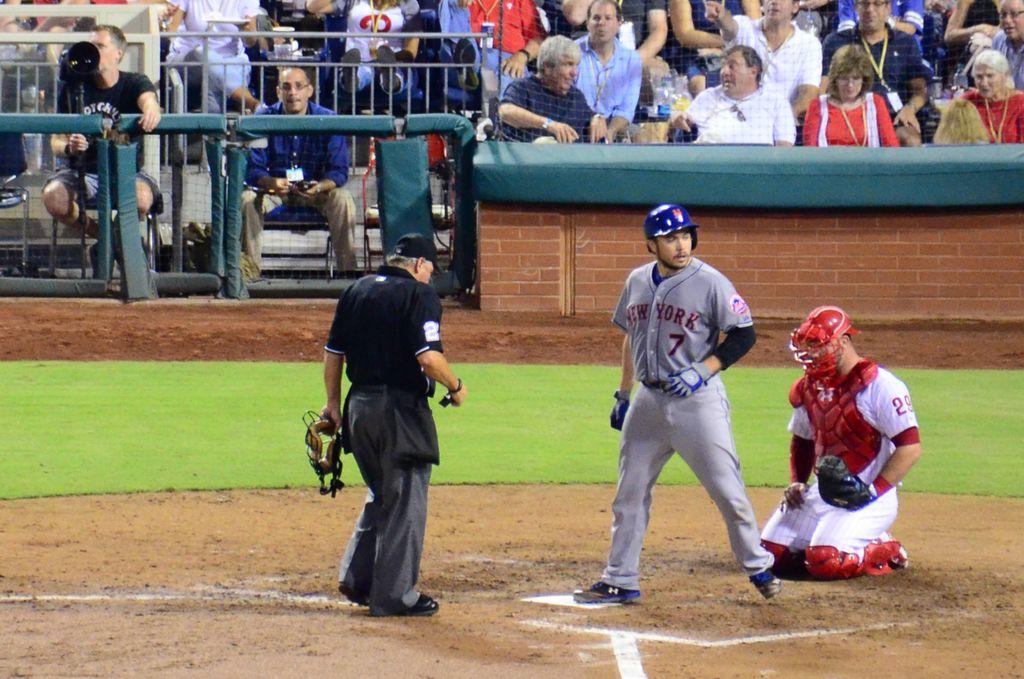What state is the man in gray playing for?
Give a very brief answer. New york. What number is on the umpires black shirt?
Your answer should be compact. 2. 